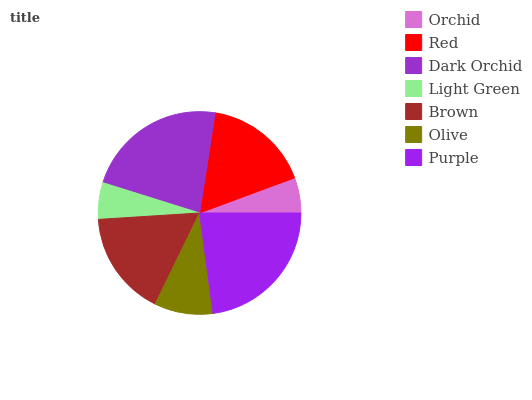Is Orchid the minimum?
Answer yes or no. Yes. Is Purple the maximum?
Answer yes or no. Yes. Is Red the minimum?
Answer yes or no. No. Is Red the maximum?
Answer yes or no. No. Is Red greater than Orchid?
Answer yes or no. Yes. Is Orchid less than Red?
Answer yes or no. Yes. Is Orchid greater than Red?
Answer yes or no. No. Is Red less than Orchid?
Answer yes or no. No. Is Brown the high median?
Answer yes or no. Yes. Is Brown the low median?
Answer yes or no. Yes. Is Red the high median?
Answer yes or no. No. Is Light Green the low median?
Answer yes or no. No. 